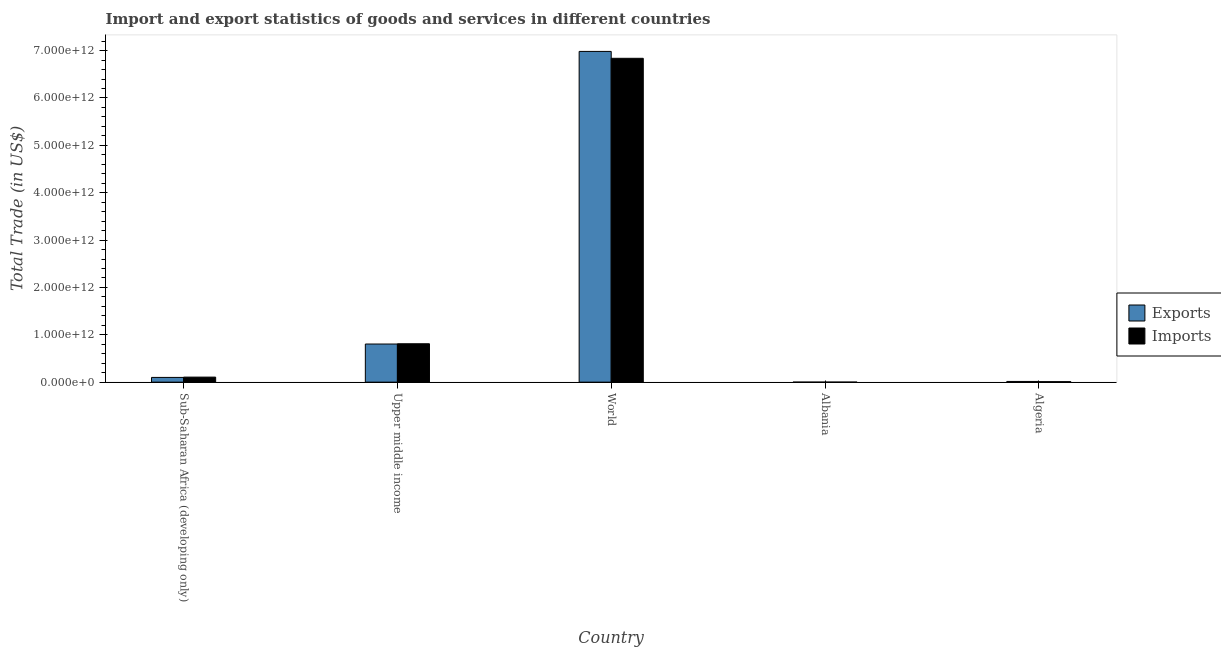How many different coloured bars are there?
Keep it short and to the point. 2. Are the number of bars on each tick of the X-axis equal?
Your answer should be compact. Yes. How many bars are there on the 5th tick from the left?
Provide a succinct answer. 2. How many bars are there on the 3rd tick from the right?
Provide a succinct answer. 2. What is the label of the 1st group of bars from the left?
Ensure brevity in your answer.  Sub-Saharan Africa (developing only). What is the imports of goods and services in World?
Keep it short and to the point. 6.84e+12. Across all countries, what is the maximum imports of goods and services?
Provide a short and direct response. 6.84e+12. Across all countries, what is the minimum export of goods and services?
Give a very brief answer. 2.30e+08. In which country was the export of goods and services maximum?
Offer a very short reply. World. In which country was the export of goods and services minimum?
Offer a very short reply. Albania. What is the total export of goods and services in the graph?
Your response must be concise. 7.90e+12. What is the difference between the export of goods and services in Algeria and that in Upper middle income?
Your response must be concise. -7.90e+11. What is the difference between the imports of goods and services in Algeria and the export of goods and services in World?
Your answer should be very brief. -6.97e+12. What is the average export of goods and services per country?
Make the answer very short. 1.58e+12. What is the difference between the export of goods and services and imports of goods and services in Algeria?
Your response must be concise. 4.61e+09. What is the ratio of the imports of goods and services in Algeria to that in Upper middle income?
Provide a succinct answer. 0.01. Is the difference between the imports of goods and services in Albania and Algeria greater than the difference between the export of goods and services in Albania and Algeria?
Provide a short and direct response. Yes. What is the difference between the highest and the second highest export of goods and services?
Provide a short and direct response. 6.18e+12. What is the difference between the highest and the lowest export of goods and services?
Your answer should be compact. 6.98e+12. In how many countries, is the imports of goods and services greater than the average imports of goods and services taken over all countries?
Keep it short and to the point. 1. What does the 2nd bar from the left in Algeria represents?
Keep it short and to the point. Imports. What does the 2nd bar from the right in World represents?
Offer a very short reply. Exports. Are all the bars in the graph horizontal?
Provide a succinct answer. No. What is the difference between two consecutive major ticks on the Y-axis?
Your answer should be very brief. 1.00e+12. Does the graph contain grids?
Offer a terse response. No. Where does the legend appear in the graph?
Provide a short and direct response. Center right. How many legend labels are there?
Your answer should be very brief. 2. How are the legend labels stacked?
Your answer should be compact. Vertical. What is the title of the graph?
Ensure brevity in your answer.  Import and export statistics of goods and services in different countries. What is the label or title of the Y-axis?
Your answer should be very brief. Total Trade (in US$). What is the Total Trade (in US$) in Exports in Sub-Saharan Africa (developing only)?
Keep it short and to the point. 1.00e+11. What is the Total Trade (in US$) in Imports in Sub-Saharan Africa (developing only)?
Your answer should be very brief. 1.06e+11. What is the Total Trade (in US$) in Exports in Upper middle income?
Your response must be concise. 8.05e+11. What is the Total Trade (in US$) of Imports in Upper middle income?
Keep it short and to the point. 8.11e+11. What is the Total Trade (in US$) of Exports in World?
Ensure brevity in your answer.  6.98e+12. What is the Total Trade (in US$) in Imports in World?
Ensure brevity in your answer.  6.84e+12. What is the Total Trade (in US$) in Exports in Albania?
Provide a short and direct response. 2.30e+08. What is the Total Trade (in US$) in Imports in Albania?
Your response must be concise. 8.07e+08. What is the Total Trade (in US$) in Exports in Algeria?
Ensure brevity in your answer.  1.49e+1. What is the Total Trade (in US$) in Imports in Algeria?
Ensure brevity in your answer.  1.03e+1. Across all countries, what is the maximum Total Trade (in US$) of Exports?
Your response must be concise. 6.98e+12. Across all countries, what is the maximum Total Trade (in US$) in Imports?
Provide a succinct answer. 6.84e+12. Across all countries, what is the minimum Total Trade (in US$) of Exports?
Offer a terse response. 2.30e+08. Across all countries, what is the minimum Total Trade (in US$) in Imports?
Give a very brief answer. 8.07e+08. What is the total Total Trade (in US$) in Exports in the graph?
Offer a terse response. 7.90e+12. What is the total Total Trade (in US$) of Imports in the graph?
Provide a short and direct response. 7.77e+12. What is the difference between the Total Trade (in US$) in Exports in Sub-Saharan Africa (developing only) and that in Upper middle income?
Provide a short and direct response. -7.05e+11. What is the difference between the Total Trade (in US$) of Imports in Sub-Saharan Africa (developing only) and that in Upper middle income?
Your response must be concise. -7.05e+11. What is the difference between the Total Trade (in US$) of Exports in Sub-Saharan Africa (developing only) and that in World?
Your answer should be very brief. -6.88e+12. What is the difference between the Total Trade (in US$) in Imports in Sub-Saharan Africa (developing only) and that in World?
Make the answer very short. -6.73e+12. What is the difference between the Total Trade (in US$) in Exports in Sub-Saharan Africa (developing only) and that in Albania?
Make the answer very short. 9.98e+1. What is the difference between the Total Trade (in US$) of Imports in Sub-Saharan Africa (developing only) and that in Albania?
Make the answer very short. 1.05e+11. What is the difference between the Total Trade (in US$) of Exports in Sub-Saharan Africa (developing only) and that in Algeria?
Your answer should be compact. 8.51e+1. What is the difference between the Total Trade (in US$) of Imports in Sub-Saharan Africa (developing only) and that in Algeria?
Your answer should be very brief. 9.58e+1. What is the difference between the Total Trade (in US$) of Exports in Upper middle income and that in World?
Your response must be concise. -6.18e+12. What is the difference between the Total Trade (in US$) in Imports in Upper middle income and that in World?
Keep it short and to the point. -6.03e+12. What is the difference between the Total Trade (in US$) of Exports in Upper middle income and that in Albania?
Make the answer very short. 8.05e+11. What is the difference between the Total Trade (in US$) in Imports in Upper middle income and that in Albania?
Offer a very short reply. 8.10e+11. What is the difference between the Total Trade (in US$) of Exports in Upper middle income and that in Algeria?
Provide a short and direct response. 7.90e+11. What is the difference between the Total Trade (in US$) of Imports in Upper middle income and that in Algeria?
Give a very brief answer. 8.00e+11. What is the difference between the Total Trade (in US$) of Exports in World and that in Albania?
Provide a short and direct response. 6.98e+12. What is the difference between the Total Trade (in US$) in Imports in World and that in Albania?
Keep it short and to the point. 6.84e+12. What is the difference between the Total Trade (in US$) in Exports in World and that in Algeria?
Ensure brevity in your answer.  6.97e+12. What is the difference between the Total Trade (in US$) of Imports in World and that in Algeria?
Ensure brevity in your answer.  6.83e+12. What is the difference between the Total Trade (in US$) in Exports in Albania and that in Algeria?
Provide a short and direct response. -1.47e+1. What is the difference between the Total Trade (in US$) of Imports in Albania and that in Algeria?
Provide a succinct answer. -9.47e+09. What is the difference between the Total Trade (in US$) in Exports in Sub-Saharan Africa (developing only) and the Total Trade (in US$) in Imports in Upper middle income?
Ensure brevity in your answer.  -7.11e+11. What is the difference between the Total Trade (in US$) in Exports in Sub-Saharan Africa (developing only) and the Total Trade (in US$) in Imports in World?
Provide a succinct answer. -6.74e+12. What is the difference between the Total Trade (in US$) in Exports in Sub-Saharan Africa (developing only) and the Total Trade (in US$) in Imports in Albania?
Provide a short and direct response. 9.92e+1. What is the difference between the Total Trade (in US$) in Exports in Sub-Saharan Africa (developing only) and the Total Trade (in US$) in Imports in Algeria?
Your answer should be very brief. 8.97e+1. What is the difference between the Total Trade (in US$) of Exports in Upper middle income and the Total Trade (in US$) of Imports in World?
Provide a succinct answer. -6.03e+12. What is the difference between the Total Trade (in US$) of Exports in Upper middle income and the Total Trade (in US$) of Imports in Albania?
Your answer should be compact. 8.04e+11. What is the difference between the Total Trade (in US$) in Exports in Upper middle income and the Total Trade (in US$) in Imports in Algeria?
Your response must be concise. 7.95e+11. What is the difference between the Total Trade (in US$) of Exports in World and the Total Trade (in US$) of Imports in Albania?
Provide a succinct answer. 6.98e+12. What is the difference between the Total Trade (in US$) of Exports in World and the Total Trade (in US$) of Imports in Algeria?
Your answer should be very brief. 6.97e+12. What is the difference between the Total Trade (in US$) of Exports in Albania and the Total Trade (in US$) of Imports in Algeria?
Your answer should be very brief. -1.01e+1. What is the average Total Trade (in US$) of Exports per country?
Your answer should be compact. 1.58e+12. What is the average Total Trade (in US$) of Imports per country?
Give a very brief answer. 1.55e+12. What is the difference between the Total Trade (in US$) in Exports and Total Trade (in US$) in Imports in Sub-Saharan Africa (developing only)?
Your answer should be compact. -6.11e+09. What is the difference between the Total Trade (in US$) of Exports and Total Trade (in US$) of Imports in Upper middle income?
Provide a succinct answer. -5.76e+09. What is the difference between the Total Trade (in US$) of Exports and Total Trade (in US$) of Imports in World?
Provide a short and direct response. 1.46e+11. What is the difference between the Total Trade (in US$) in Exports and Total Trade (in US$) in Imports in Albania?
Make the answer very short. -5.77e+08. What is the difference between the Total Trade (in US$) in Exports and Total Trade (in US$) in Imports in Algeria?
Provide a short and direct response. 4.61e+09. What is the ratio of the Total Trade (in US$) of Exports in Sub-Saharan Africa (developing only) to that in Upper middle income?
Keep it short and to the point. 0.12. What is the ratio of the Total Trade (in US$) in Imports in Sub-Saharan Africa (developing only) to that in Upper middle income?
Provide a succinct answer. 0.13. What is the ratio of the Total Trade (in US$) in Exports in Sub-Saharan Africa (developing only) to that in World?
Your response must be concise. 0.01. What is the ratio of the Total Trade (in US$) of Imports in Sub-Saharan Africa (developing only) to that in World?
Offer a terse response. 0.02. What is the ratio of the Total Trade (in US$) of Exports in Sub-Saharan Africa (developing only) to that in Albania?
Offer a very short reply. 434.83. What is the ratio of the Total Trade (in US$) in Imports in Sub-Saharan Africa (developing only) to that in Albania?
Your response must be concise. 131.52. What is the ratio of the Total Trade (in US$) of Exports in Sub-Saharan Africa (developing only) to that in Algeria?
Make the answer very short. 6.72. What is the ratio of the Total Trade (in US$) in Imports in Sub-Saharan Africa (developing only) to that in Algeria?
Offer a very short reply. 10.32. What is the ratio of the Total Trade (in US$) in Exports in Upper middle income to that in World?
Offer a very short reply. 0.12. What is the ratio of the Total Trade (in US$) in Imports in Upper middle income to that in World?
Keep it short and to the point. 0.12. What is the ratio of the Total Trade (in US$) in Exports in Upper middle income to that in Albania?
Give a very brief answer. 3499.92. What is the ratio of the Total Trade (in US$) in Imports in Upper middle income to that in Albania?
Give a very brief answer. 1004.77. What is the ratio of the Total Trade (in US$) of Exports in Upper middle income to that in Algeria?
Your answer should be very brief. 54.06. What is the ratio of the Total Trade (in US$) in Imports in Upper middle income to that in Algeria?
Your response must be concise. 78.86. What is the ratio of the Total Trade (in US$) of Exports in World to that in Albania?
Keep it short and to the point. 3.04e+04. What is the ratio of the Total Trade (in US$) in Imports in World to that in Albania?
Make the answer very short. 8474.6. What is the ratio of the Total Trade (in US$) of Exports in World to that in Algeria?
Ensure brevity in your answer.  468.99. What is the ratio of the Total Trade (in US$) of Imports in World to that in Algeria?
Your answer should be compact. 665.15. What is the ratio of the Total Trade (in US$) of Exports in Albania to that in Algeria?
Your response must be concise. 0.02. What is the ratio of the Total Trade (in US$) of Imports in Albania to that in Algeria?
Ensure brevity in your answer.  0.08. What is the difference between the highest and the second highest Total Trade (in US$) in Exports?
Make the answer very short. 6.18e+12. What is the difference between the highest and the second highest Total Trade (in US$) of Imports?
Offer a terse response. 6.03e+12. What is the difference between the highest and the lowest Total Trade (in US$) in Exports?
Your response must be concise. 6.98e+12. What is the difference between the highest and the lowest Total Trade (in US$) of Imports?
Provide a short and direct response. 6.84e+12. 